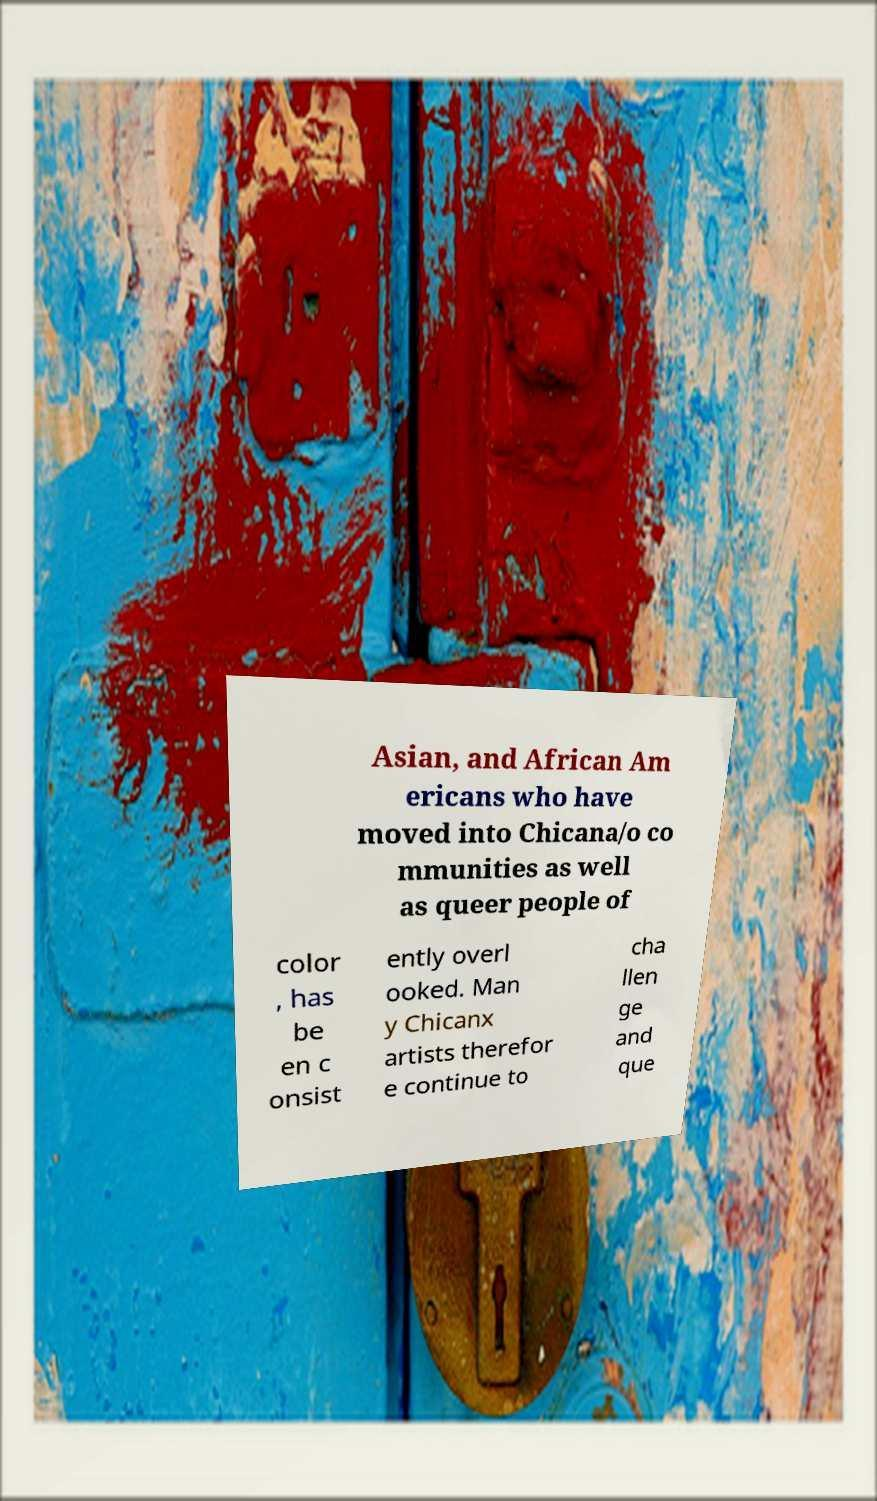What messages or text are displayed in this image? I need them in a readable, typed format. Asian, and African Am ericans who have moved into Chicana/o co mmunities as well as queer people of color , has be en c onsist ently overl ooked. Man y Chicanx artists therefor e continue to cha llen ge and que 